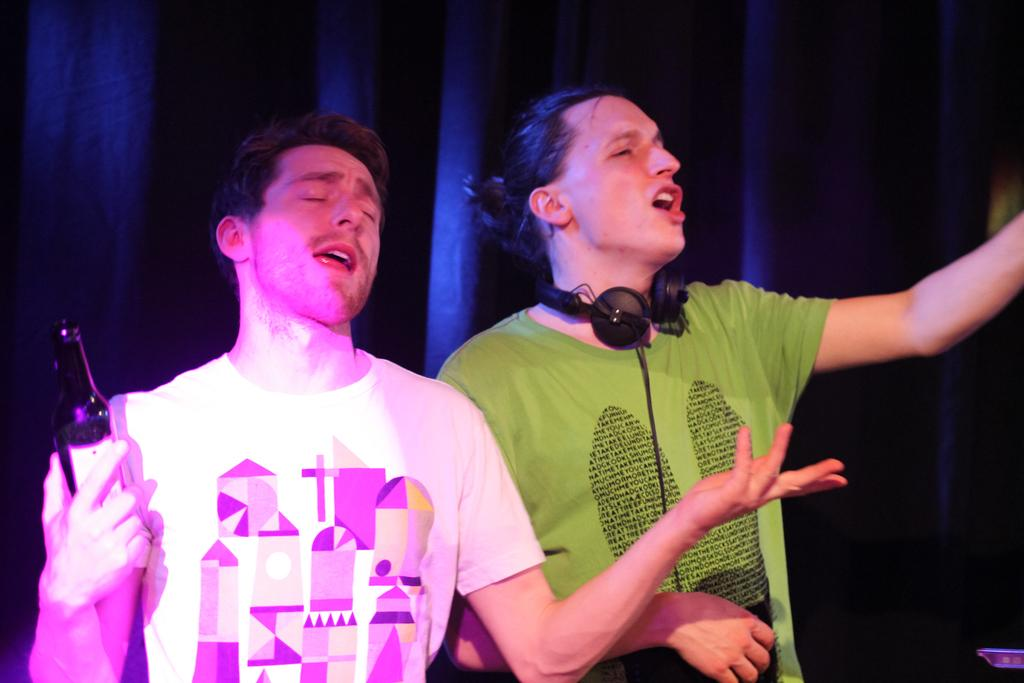What is the man on the right side of the image wearing? The man on the right side of the image is wearing a green t-shirt. What might the man in the green t-shirt be doing? The man in the green t-shirt may be singing. What is the man on the left side of the image wearing? The man on the left side of the image is wearing a white t-shirt. What is the man in the white t-shirt holding? The man in the white t-shirt is holding a bottle in his hands. What might the man in the white t-shirt be doing? The man in the white t-shirt may also be singing. What type of juice is being squeezed out of the cast in the image? There is no cast or juice present in the image. 